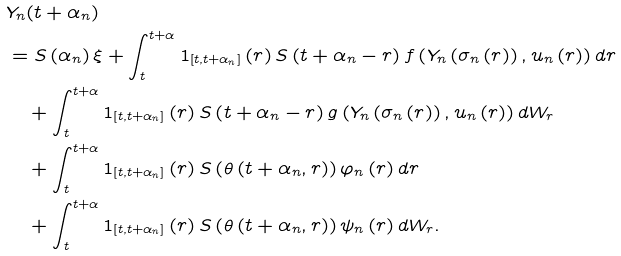<formula> <loc_0><loc_0><loc_500><loc_500>& Y _ { n } ( t + \alpha _ { n } ) \\ & = S \left ( \alpha _ { n } \right ) \xi + \int _ { t } ^ { t + \alpha } 1 _ { \left [ t , t + \alpha _ { n } \right ] } \left ( r \right ) S \left ( t + \alpha _ { n } - r \right ) f \left ( Y _ { n } \left ( \sigma _ { n } \left ( r \right ) \right ) , u _ { n } \left ( r \right ) \right ) d r \\ & \text { \ \ } + \int _ { t } ^ { t + \alpha } 1 _ { \left [ t , t + \alpha _ { n } \right ] } \left ( r \right ) S \left ( t + \alpha _ { n } - r \right ) g \left ( Y _ { n } \left ( \sigma _ { n } \left ( r \right ) \right ) , u _ { n } \left ( r \right ) \right ) d W _ { r } \\ & \text { \ \ } + \int _ { t } ^ { t + \alpha } 1 _ { \left [ t , t + \alpha _ { n } \right ] } \left ( r \right ) S \left ( \theta \left ( t + \alpha _ { n } , r \right ) \right ) \varphi _ { n } \left ( r \right ) d r \\ & \text { \ \ } + \int _ { t } ^ { t + \alpha } 1 _ { \left [ t , t + \alpha _ { n } \right ] } \left ( r \right ) S \left ( \theta \left ( t + \alpha _ { n } , r \right ) \right ) \psi _ { n } \left ( r \right ) d W _ { r } .</formula> 